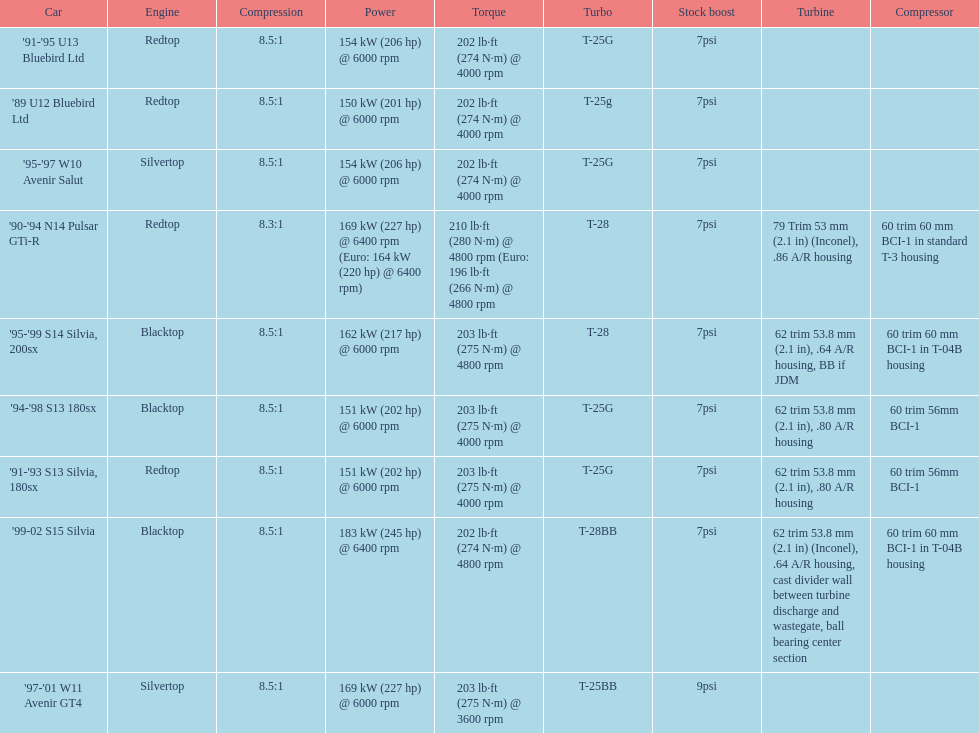Which engine(s) has the least amount of power? Redtop. 